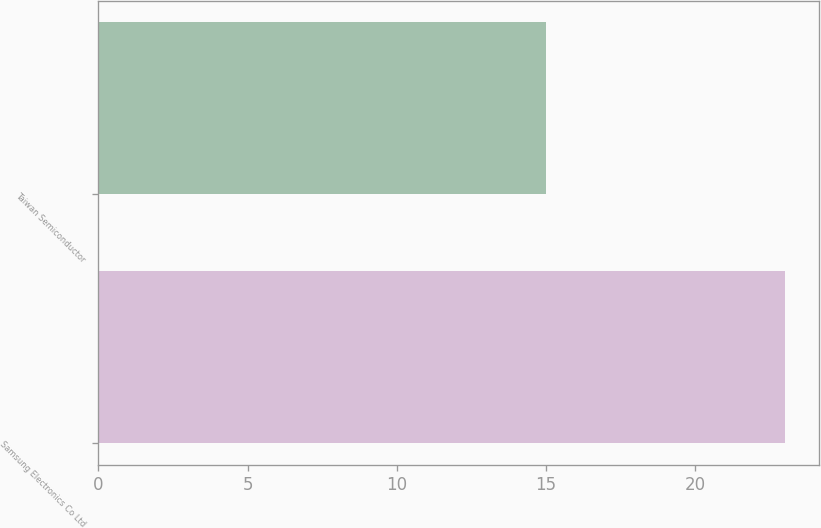<chart> <loc_0><loc_0><loc_500><loc_500><bar_chart><fcel>Samsung Electronics Co Ltd<fcel>Taiwan Semiconductor<nl><fcel>23<fcel>15<nl></chart> 